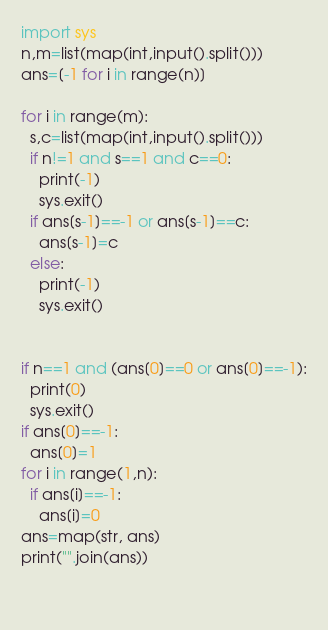Convert code to text. <code><loc_0><loc_0><loc_500><loc_500><_Python_>import sys
n,m=list(map(int,input().split()))
ans=[-1 for i in range(n)]

for i in range(m):
  s,c=list(map(int,input().split()))
  if n!=1 and s==1 and c==0:
    print(-1)
    sys.exit()
  if ans[s-1]==-1 or ans[s-1]==c:
    ans[s-1]=c
  else:
    print(-1)
    sys.exit()

    
if n==1 and (ans[0]==0 or ans[0]==-1):
  print(0)
  sys.exit()
if ans[0]==-1:
  ans[0]=1
for i in range(1,n):
  if ans[i]==-1:
    ans[i]=0
ans=map(str, ans)
print("".join(ans))

  </code> 